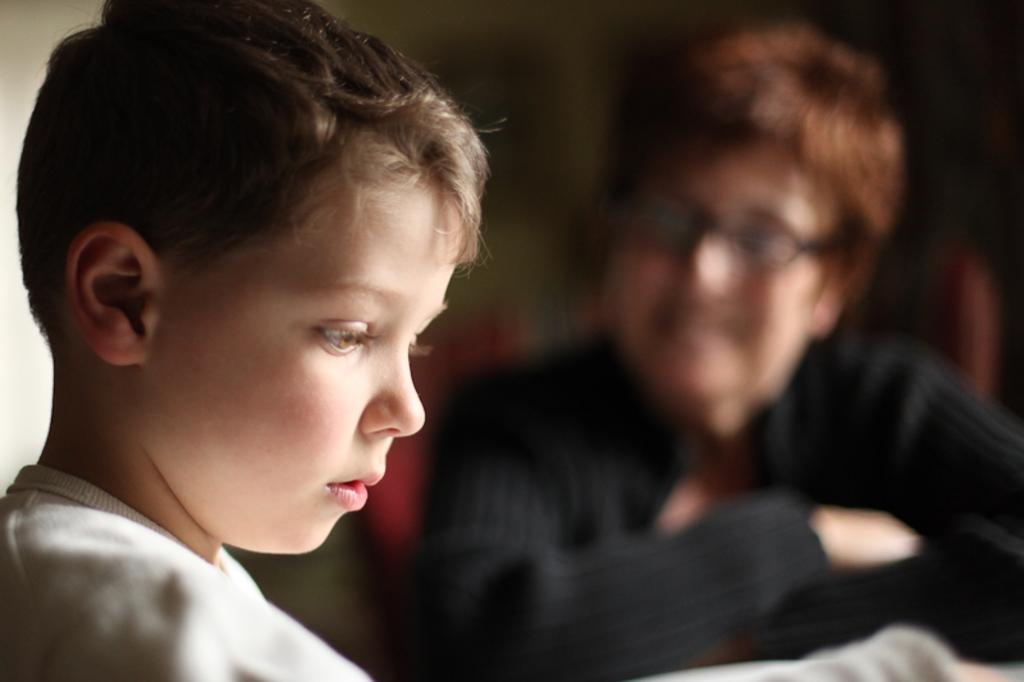Who is present in the image? There is a boy and a person in the image. Can you describe the boy in the image? The provided facts do not give specific details about the boy's appearance or actions. What can be observed about the background of the image? The background of the image is blurred. Can you tell me how many animals can be seen at the zoo in the image? There is no zoo present in the image, so it is not possible to determine how many animals might be there. 